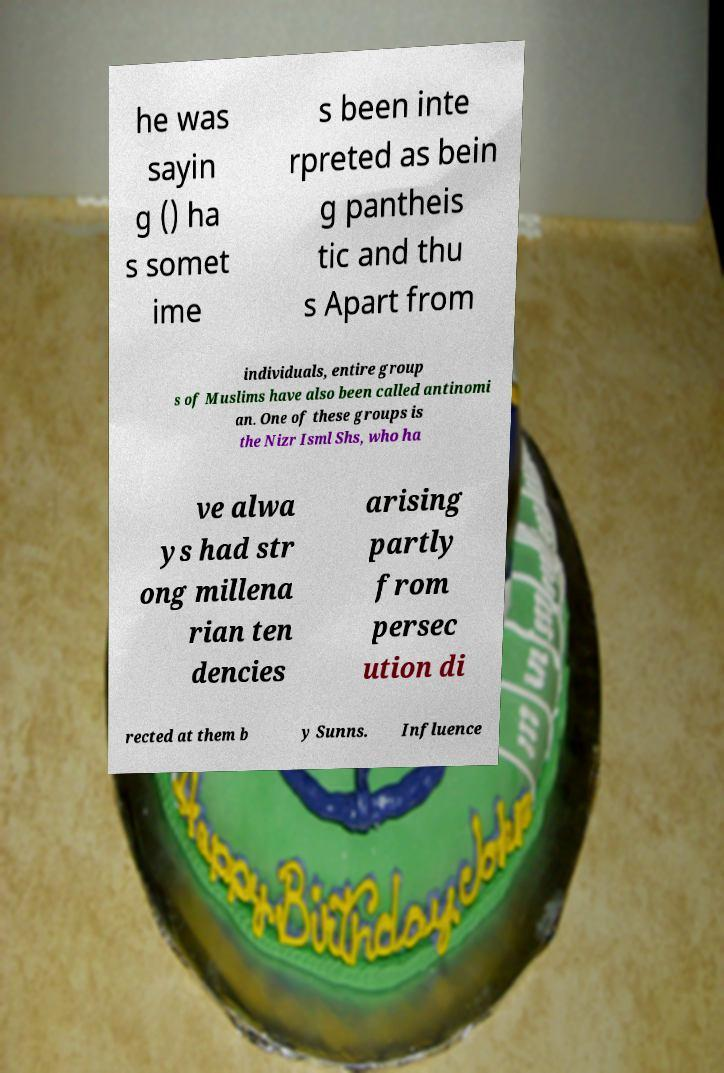Please read and relay the text visible in this image. What does it say? he was sayin g () ha s somet ime s been inte rpreted as bein g pantheis tic and thu s Apart from individuals, entire group s of Muslims have also been called antinomi an. One of these groups is the Nizr Isml Shs, who ha ve alwa ys had str ong millena rian ten dencies arising partly from persec ution di rected at them b y Sunns. Influence 